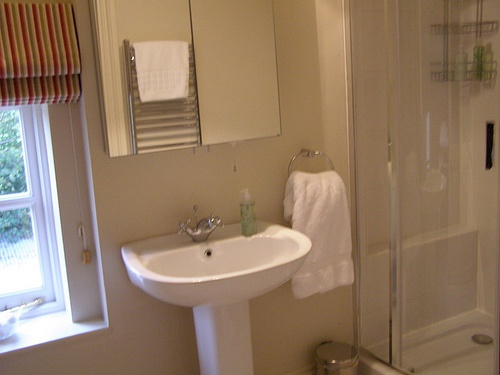Describe the objects in this image and their specific colors. I can see sink in brown, gray, tan, and lightgray tones and bottle in brown, olive, and gray tones in this image. 